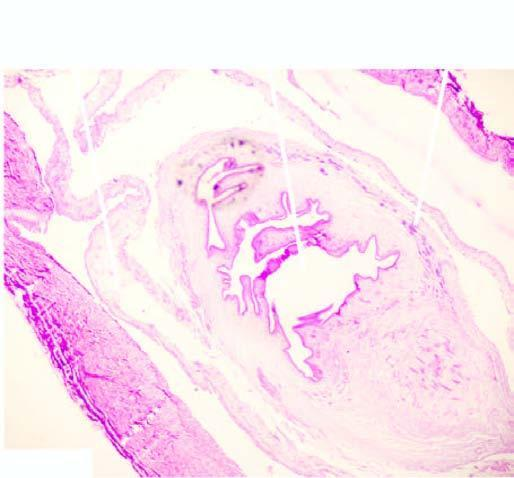what is seen in the cyst while the cyst wall shows palisade layer of histiocytes?
Answer the question using a single word or phrase. Worm 